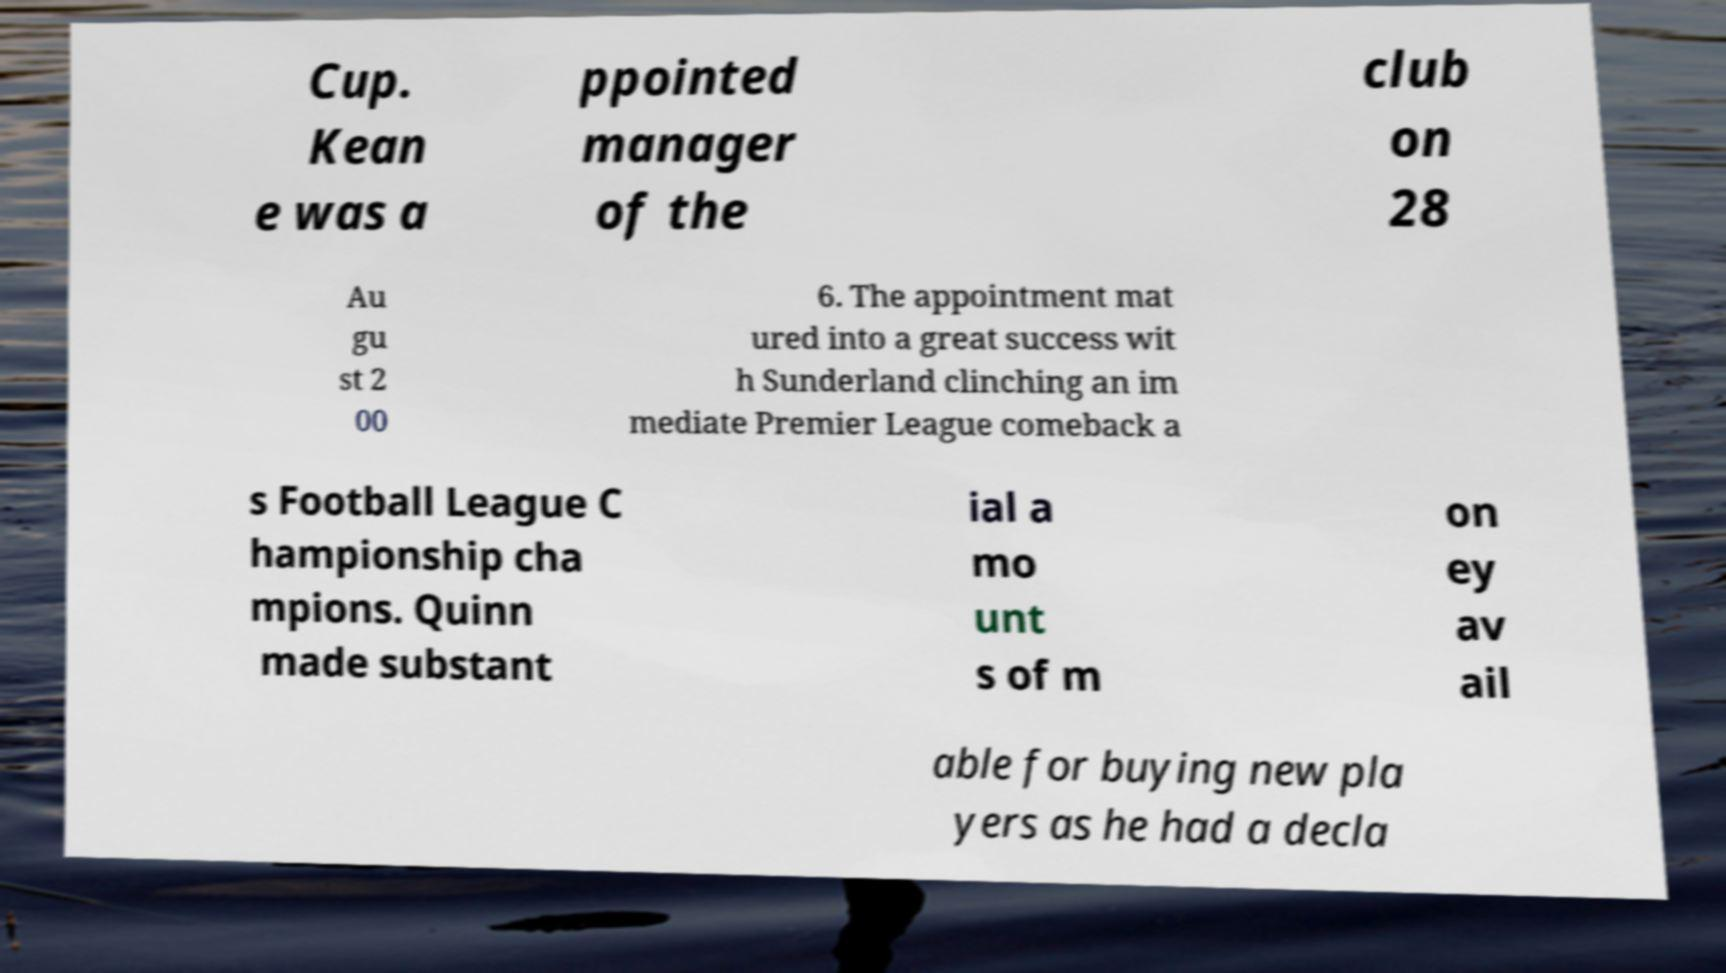Could you extract and type out the text from this image? Cup. Kean e was a ppointed manager of the club on 28 Au gu st 2 00 6. The appointment mat ured into a great success wit h Sunderland clinching an im mediate Premier League comeback a s Football League C hampionship cha mpions. Quinn made substant ial a mo unt s of m on ey av ail able for buying new pla yers as he had a decla 